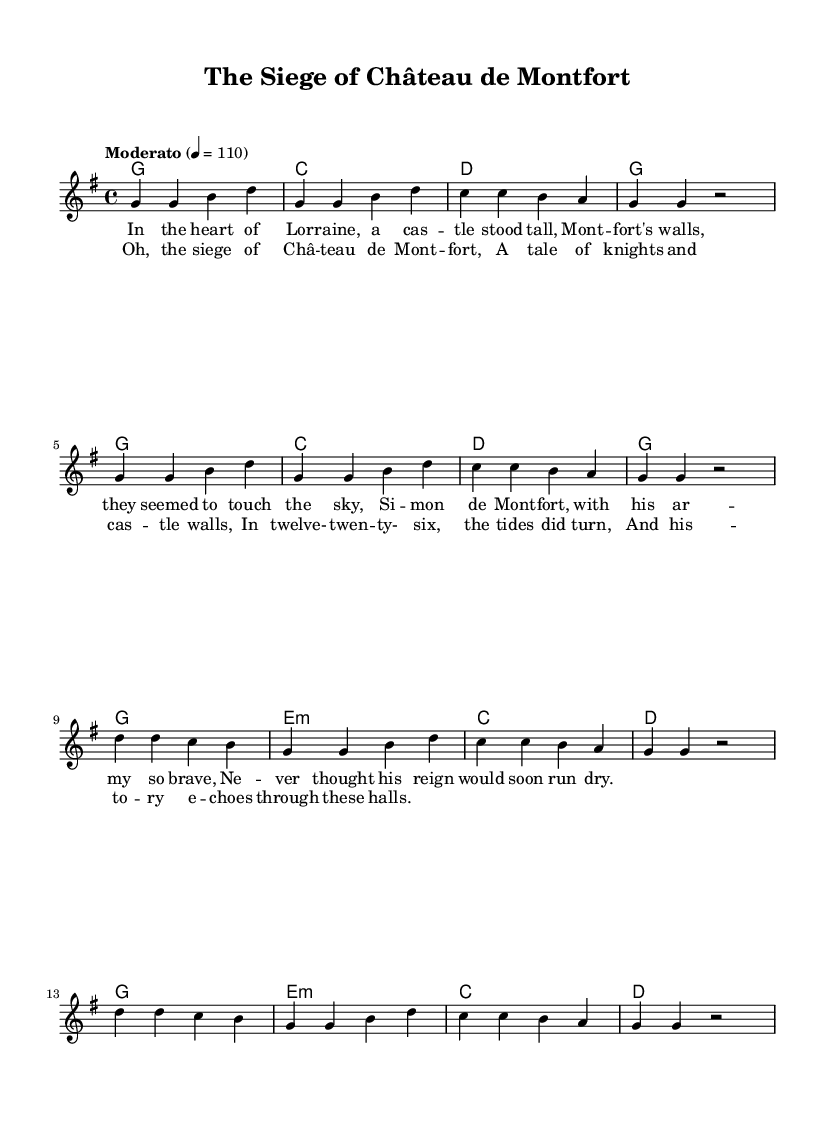What is the key signature of this music? The key signature is G major, which has one sharp (F#). It can be identified by looking at the key signature located at the beginning of the staff, right after the clef sign.
Answer: G major What is the time signature of this music? The time signature is 4/4, which indicates that each measure contains four beats and that each beat is a quarter note. This can be observed in the notation just after the key signature and before the first note.
Answer: 4/4 What is the tempo marking of the piece? The tempo marking is "Moderato", and it indicates a moderate speed which is expressed as beats per minute (BPM). In this case, it is notated as 4 = 110, meaning there are 110 beats per minute. This is found in the header section above the music.
Answer: Moderato How many verses are in the piece? There are two verses, as indicated by the repetition of the lyric sections in the music notation. Each verse is notated and separated from the chorus, showing that the song has a structured format with multiple sections.
Answer: 2 What year does the historical event take place? The historical event referred to in the song takes place in the year 1226, as indicated in the chorus lyrics, which state "In twelve-twenty-six, the tides did turn." This specific year is essential to the context of the song and reflects on the historical theme.
Answer: 1226 What type of music is this sheet representing? This sheet represents a modern country song that combines storytelling with a historical event from the Middle Ages, evident through the lyrics about the siege of a castle and the narrative style typical of country music. The lyrical content describes historical events using a contemporary musical form.
Answer: Modern country 